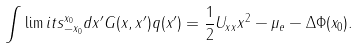<formula> <loc_0><loc_0><loc_500><loc_500>\int \lim i t s _ { - x _ { 0 } } ^ { x _ { 0 } } d x ^ { \prime } G ( x , x ^ { \prime } ) q ( x ^ { \prime } ) = \frac { 1 } { 2 } U _ { x x } x ^ { 2 } - \mu _ { e } - \Delta \Phi ( x _ { 0 } ) .</formula> 